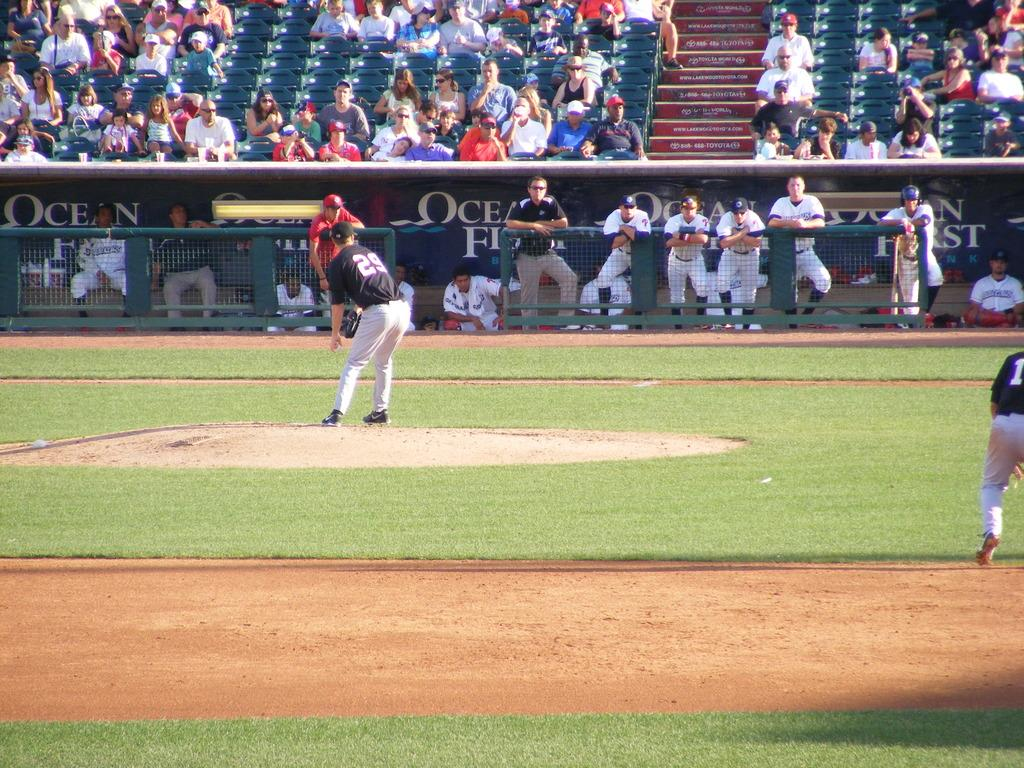<image>
Summarize the visual content of the image. Several baseball players are on the field including one in a number 29 jersey 